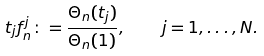<formula> <loc_0><loc_0><loc_500><loc_500>t _ { j } f ^ { j } _ { n } \colon = \frac { \Theta _ { n } ( t _ { j } ) } { \Theta _ { n } ( 1 ) } , \quad j = 1 , \dots , N .</formula> 